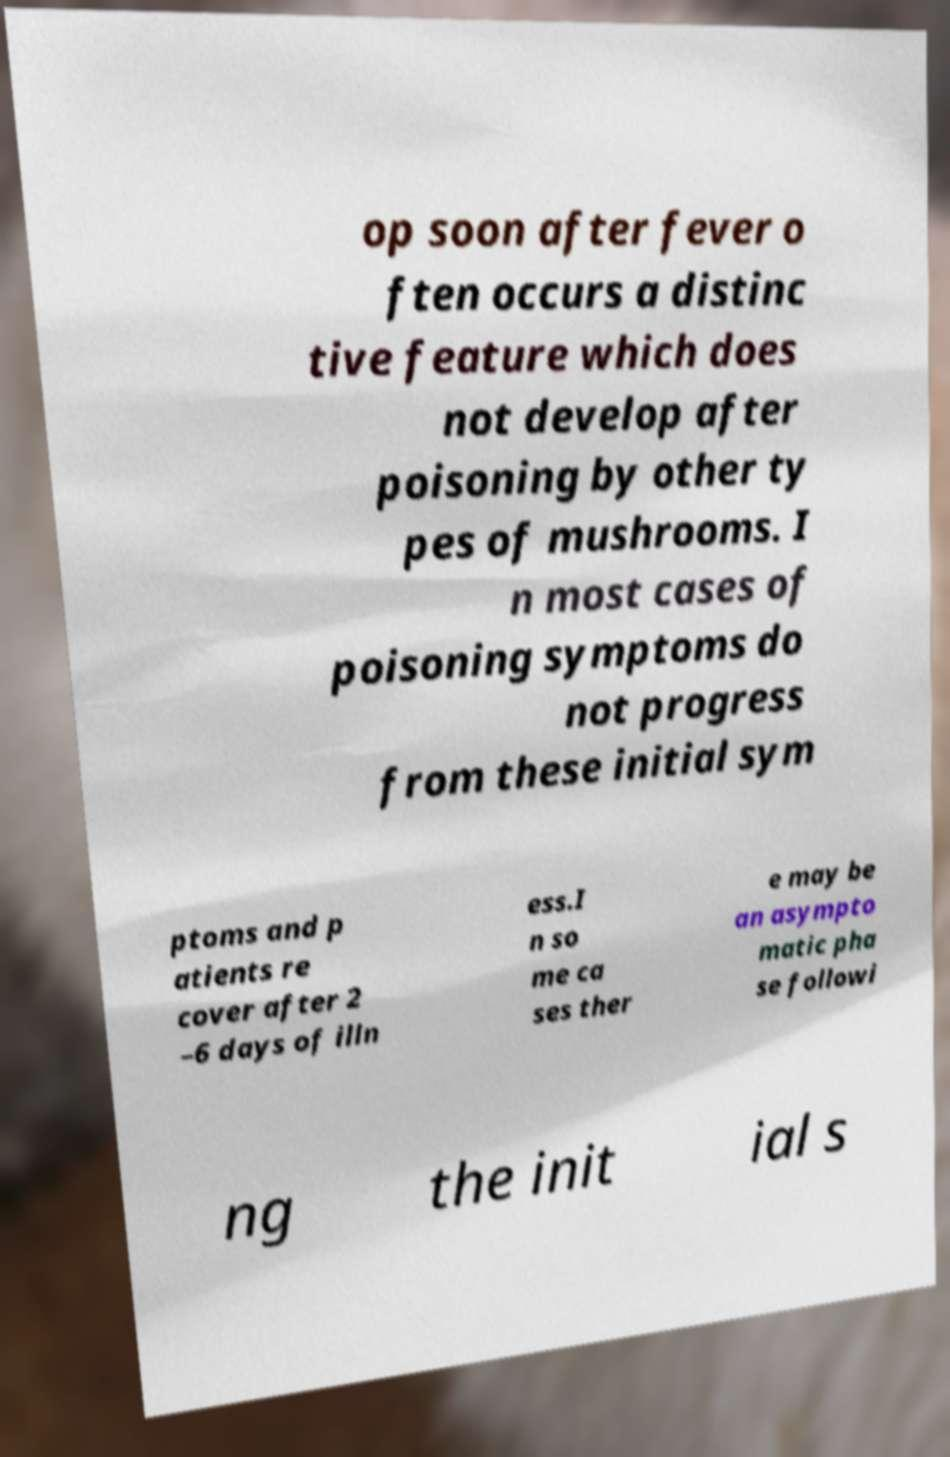Please identify and transcribe the text found in this image. op soon after fever o ften occurs a distinc tive feature which does not develop after poisoning by other ty pes of mushrooms. I n most cases of poisoning symptoms do not progress from these initial sym ptoms and p atients re cover after 2 –6 days of illn ess.I n so me ca ses ther e may be an asympto matic pha se followi ng the init ial s 